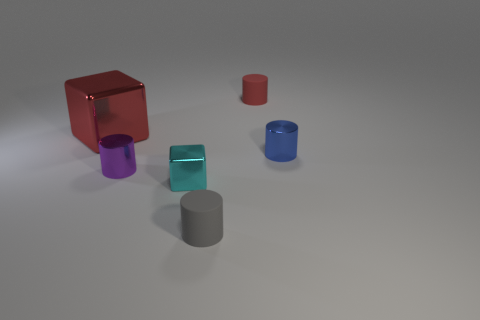Are there any other things that are the same size as the blue metallic thing?
Your answer should be compact. Yes. Is the number of tiny purple shiny things that are in front of the purple shiny cylinder less than the number of large brown rubber spheres?
Provide a short and direct response. No. Is the shape of the red rubber object the same as the large metal thing?
Your response must be concise. No. There is another metallic object that is the same shape as the red metal object; what color is it?
Ensure brevity in your answer.  Cyan. What number of small metallic objects are the same color as the tiny metallic cube?
Provide a succinct answer. 0. How many objects are red things that are to the left of the gray rubber cylinder or tiny cylinders?
Provide a succinct answer. 5. There is a shiny cylinder that is to the left of the cyan metal object; what size is it?
Offer a very short reply. Small. Is the number of cyan blocks less than the number of tiny rubber cylinders?
Provide a succinct answer. Yes. Does the small object behind the blue thing have the same material as the cylinder in front of the cyan shiny block?
Ensure brevity in your answer.  Yes. What is the shape of the red thing that is right of the tiny rubber thing that is in front of the tiny metal cylinder that is left of the small blue thing?
Keep it short and to the point. Cylinder. 